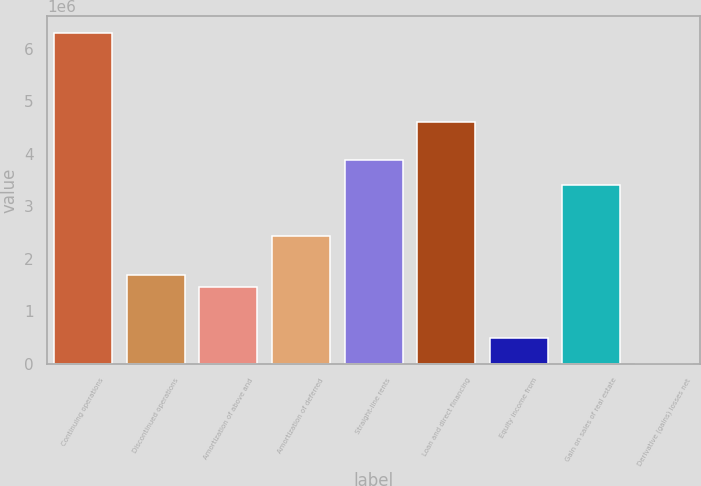<chart> <loc_0><loc_0><loc_500><loc_500><bar_chart><fcel>Continuing operations<fcel>Discontinued operations<fcel>Amortization of above and<fcel>Amortization of deferred<fcel>Straight-line rents<fcel>Loan and direct financing<fcel>Equity income from<fcel>Gain on sales of real estate<fcel>Derivative (gains) losses net<nl><fcel>6.30786e+06<fcel>1.69922e+06<fcel>1.45666e+06<fcel>2.4269e+06<fcel>3.88226e+06<fcel>4.60994e+06<fcel>486422<fcel>3.39714e+06<fcel>1302<nl></chart> 